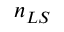<formula> <loc_0><loc_0><loc_500><loc_500>n _ { L S }</formula> 